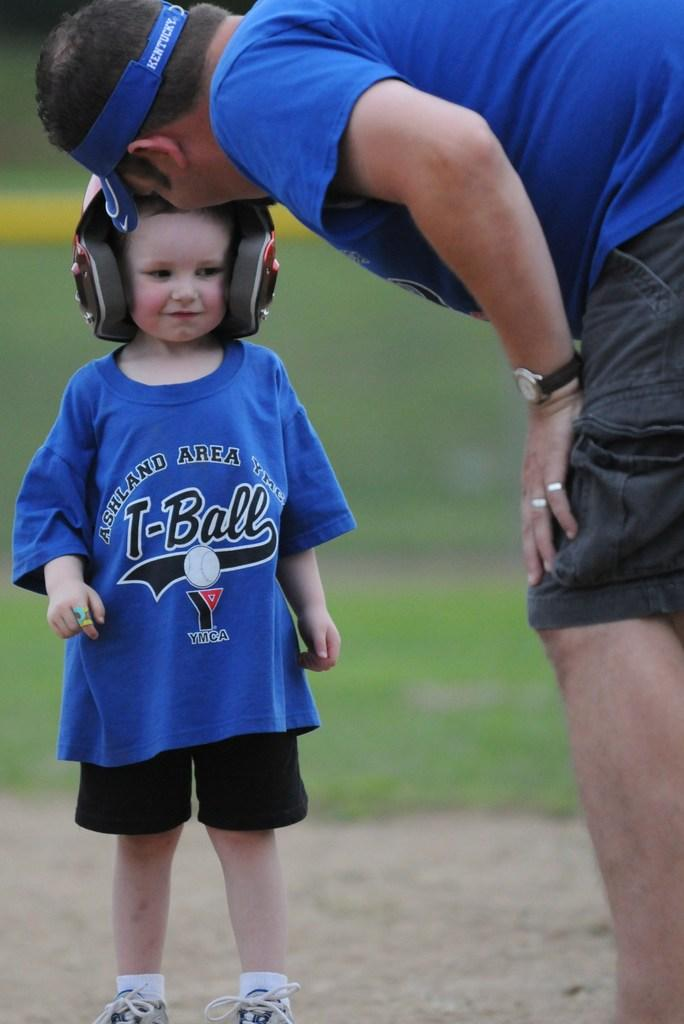<image>
Present a compact description of the photo's key features. a man and a child in blue t shirts with ashland area written on them 